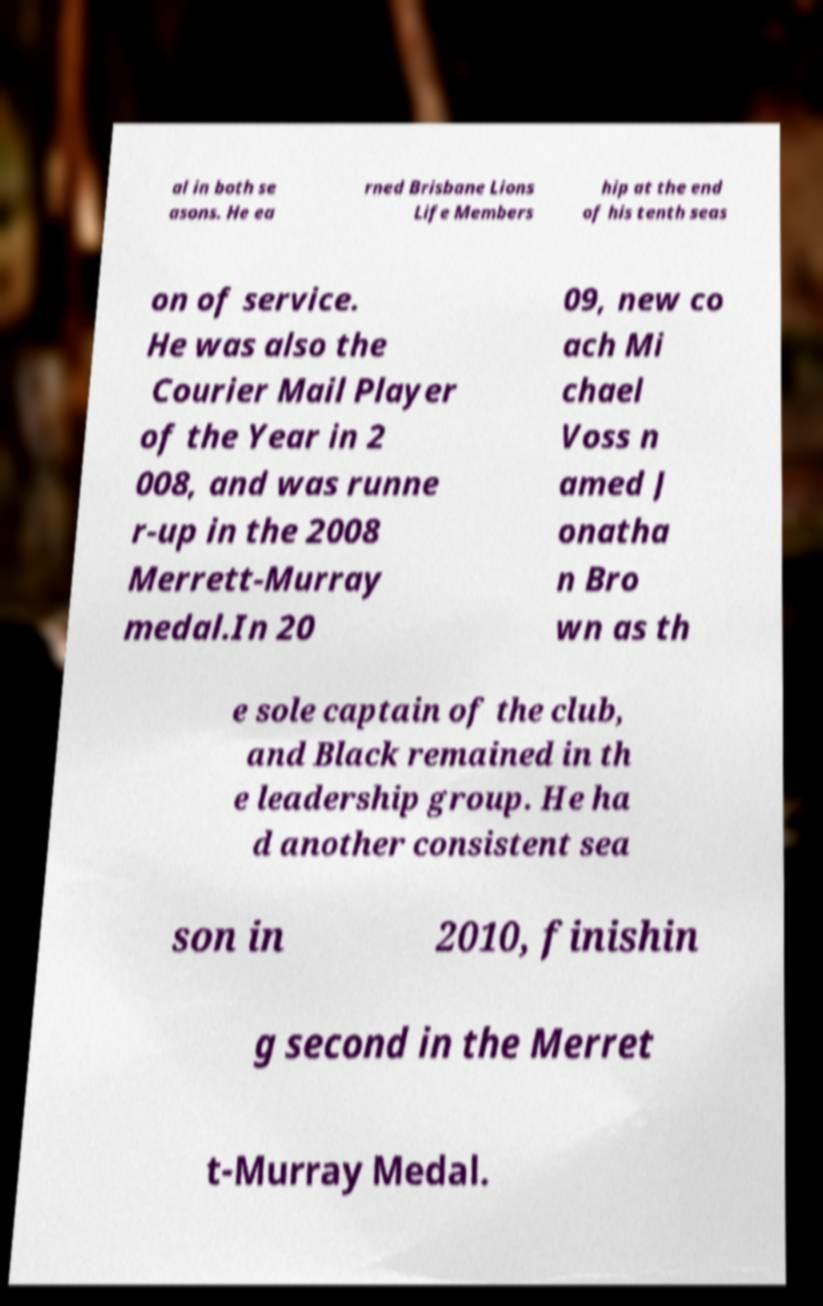Please read and relay the text visible in this image. What does it say? al in both se asons. He ea rned Brisbane Lions Life Members hip at the end of his tenth seas on of service. He was also the Courier Mail Player of the Year in 2 008, and was runne r-up in the 2008 Merrett-Murray medal.In 20 09, new co ach Mi chael Voss n amed J onatha n Bro wn as th e sole captain of the club, and Black remained in th e leadership group. He ha d another consistent sea son in 2010, finishin g second in the Merret t-Murray Medal. 